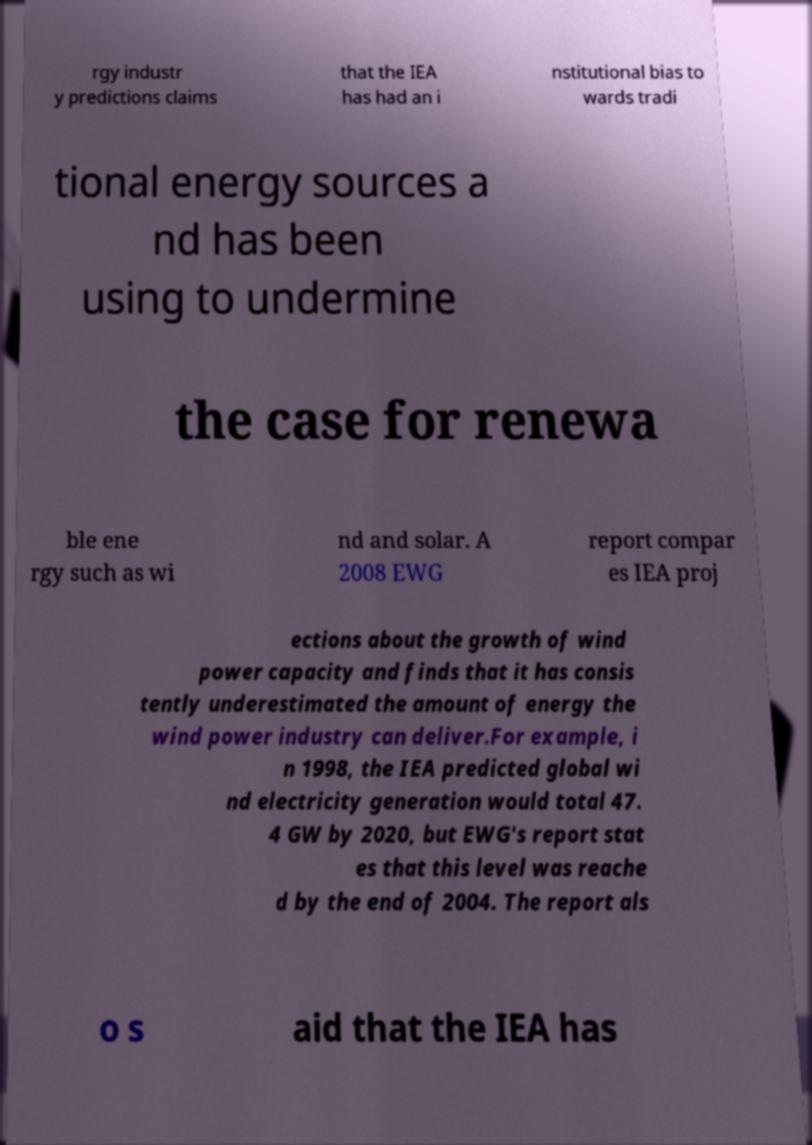Please read and relay the text visible in this image. What does it say? rgy industr y predictions claims that the IEA has had an i nstitutional bias to wards tradi tional energy sources a nd has been using to undermine the case for renewa ble ene rgy such as wi nd and solar. A 2008 EWG report compar es IEA proj ections about the growth of wind power capacity and finds that it has consis tently underestimated the amount of energy the wind power industry can deliver.For example, i n 1998, the IEA predicted global wi nd electricity generation would total 47. 4 GW by 2020, but EWG's report stat es that this level was reache d by the end of 2004. The report als o s aid that the IEA has 